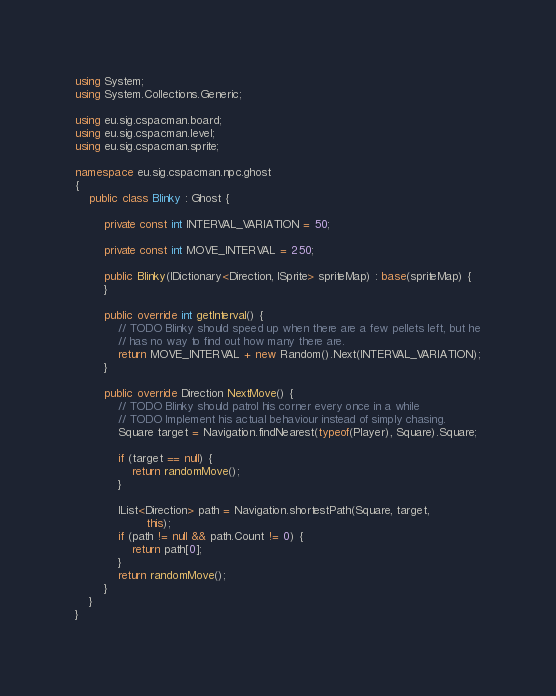<code> <loc_0><loc_0><loc_500><loc_500><_C#_>using System;
using System.Collections.Generic;

using eu.sig.cspacman.board;
using eu.sig.cspacman.level;
using eu.sig.cspacman.sprite;

namespace eu.sig.cspacman.npc.ghost
{
	public class Blinky : Ghost {

		private const int INTERVAL_VARIATION = 50;

		private const int MOVE_INTERVAL = 250;

		public Blinky(IDictionary<Direction, ISprite> spriteMap) : base(spriteMap) {
		}

		public override int getInterval() {
			// TODO Blinky should speed up when there are a few pellets left, but he
			// has no way to find out how many there are.
			return MOVE_INTERVAL + new Random().Next(INTERVAL_VARIATION);
		}

		public override Direction NextMove() {
			// TODO Blinky should patrol his corner every once in a while
			// TODO Implement his actual behaviour instead of simply chasing.
			Square target = Navigation.findNearest(typeof(Player), Square).Square;

			if (target == null) {
				return randomMove();
			}

			IList<Direction> path = Navigation.shortestPath(Square, target,
					this);
			if (path != null && path.Count != 0) {
				return path[0];
			}
			return randomMove();
		}
	}
}
</code> 